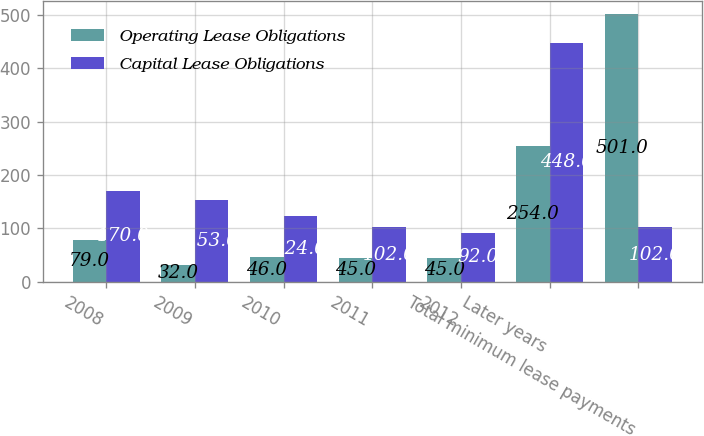<chart> <loc_0><loc_0><loc_500><loc_500><stacked_bar_chart><ecel><fcel>2008<fcel>2009<fcel>2010<fcel>2011<fcel>2012<fcel>Later years<fcel>Total minimum lease payments<nl><fcel>Operating Lease Obligations<fcel>79<fcel>32<fcel>46<fcel>45<fcel>45<fcel>254<fcel>501<nl><fcel>Capital Lease Obligations<fcel>170<fcel>153<fcel>124<fcel>102<fcel>92<fcel>448<fcel>102<nl></chart> 